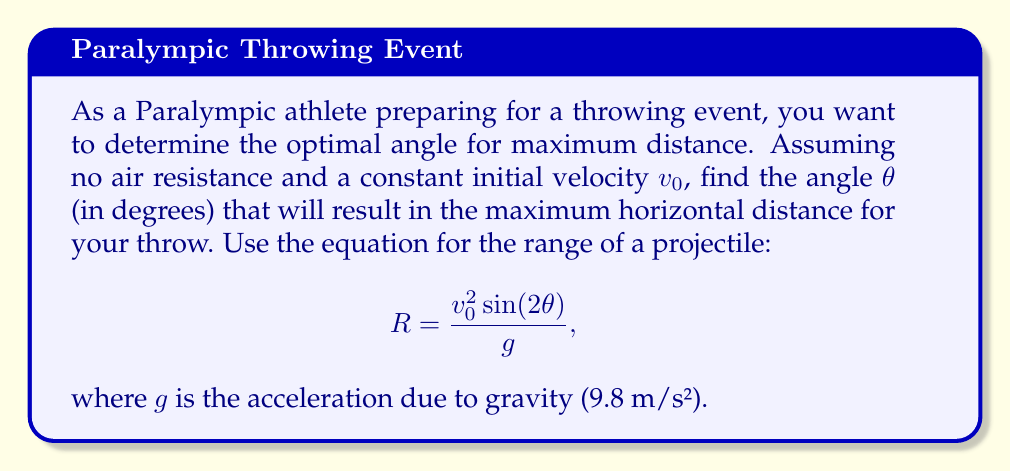What is the answer to this math problem? To find the optimal angle for maximum distance, we need to maximize the range equation:

$$R = \frac{v_0^2 \sin(2\theta)}{g}$$

The only variable in this equation that we can control is $\theta$. To find the maximum value of $R$, we need to find the value of $\theta$ that maximizes $\sin(2\theta)$.

1) The sine function reaches its maximum value of 1 when its argument is 90°.

2) Therefore, we want:

   $$2\theta = 90°$$

3) Solving for $\theta$:

   $$\theta = 45°$$

4) To verify this is a maximum and not a minimum, we can consider the behavior of $\sin(2\theta)$:
   - For angles slightly less than 45°, $\sin(2\theta)$ increases.
   - For angles slightly more than 45°, $\sin(2\theta)$ decreases.

This confirms that 45° is indeed the angle that maximizes the range.

5) It's worth noting that this result is independent of the initial velocity $v_0$ and the acceleration due to gravity $g$. It applies to all projectile motions in a uniform gravitational field without air resistance.

[asy]
import graph;
size(200,200);
real f(real x) {return sin(2*x);}
draw(graph(f,0,pi/2));
draw((0,0)--(pi/2,0),arrow=Arrow(TeXHead));
draw((0,0)--(0,1),arrow=Arrow(TeXHead));
label("$\theta$",(pi/2,-.1),E);
label("$\sin(2\theta)$",(-.1,1),W);
dot((pi/4,1));
label("(45°, 1)",(pi/4,1),NE);
[/asy]

This graph shows $\sin(2\theta)$ reaching its maximum at $\theta = 45°$.
Answer: The optimal angle for maximum distance in a throwing event is 45°. 